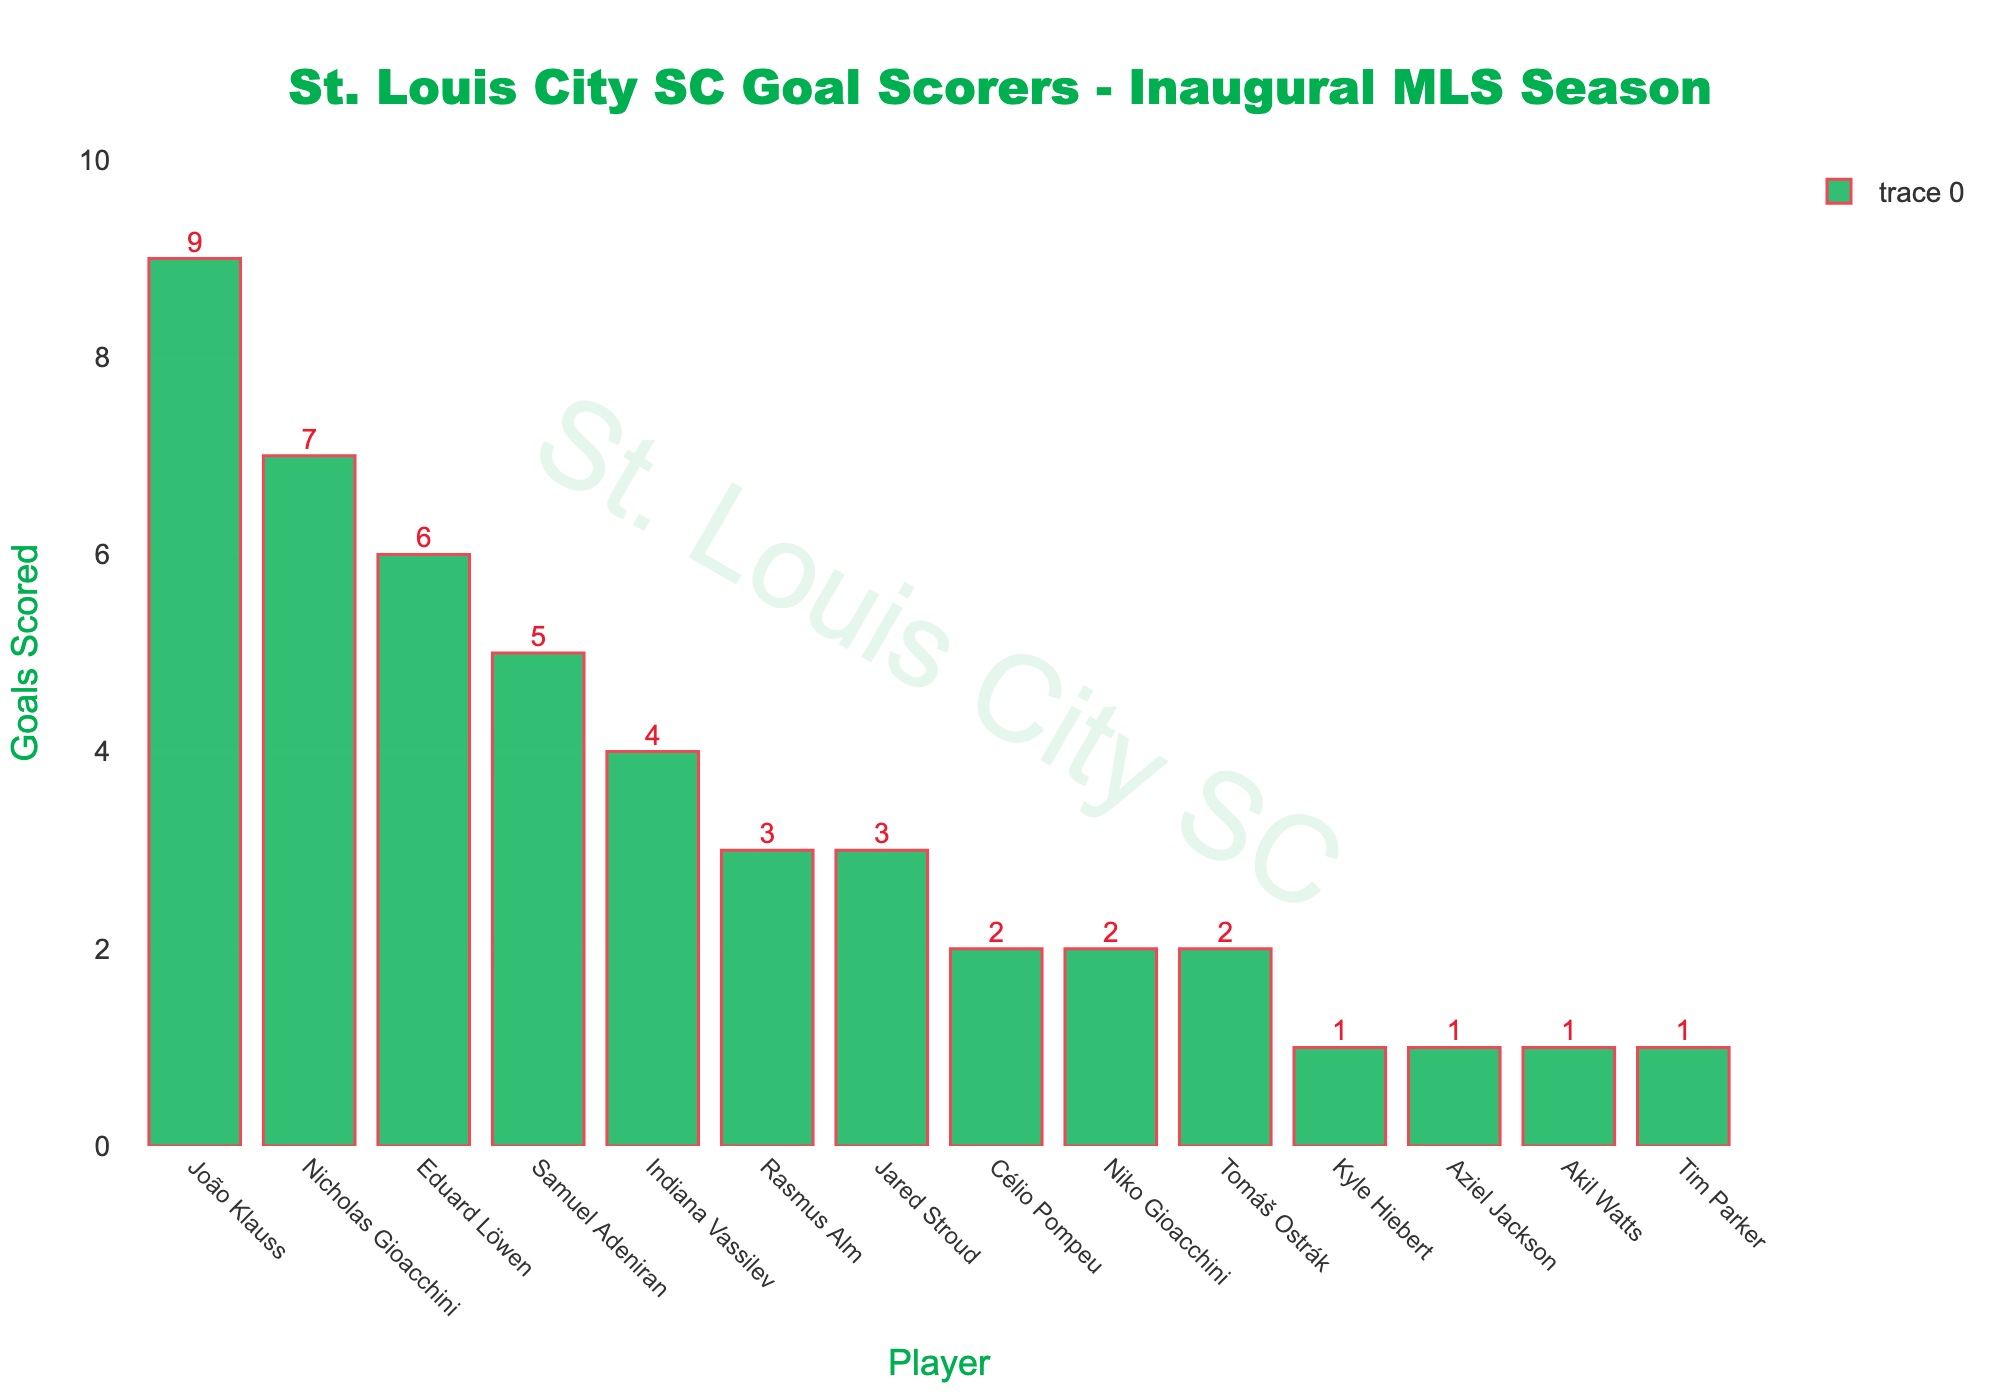What's the total number of goals scored by the top three goal scorers? The top three goal scorers are João Klauss (9 goals), Nicholas Gioacchini (7 goals), and Eduard Löwen (6 goals). Adding their goals together: 9 + 7 + 6 = 22.
Answer: 22 Who scored more goals, Indiana Vassilev or Samuel Adeniran? According to the bar chart, Indiana Vassilev scored 4 goals, while Samuel Adeniran scored 5 goals. Therefore, Samuel Adeniran scored more goals.
Answer: Samuel Adeniran What is the difference in goals scored between the player with the most goals and the player with the least goals? The player with the most goals is João Klauss with 9 goals. The players with the least goals (1 each) are Kyle Hiebert, Aziel Jackson, Akil Watts, and Tim Parker. The difference between 9 (most goals) and 1 (least goals) is: 9 - 1 = 8.
Answer: 8 Which players scored exactly 3 goals? The bar chart shows that both Rasmus Alm and Jared Stroud scored exactly 3 goals each.
Answer: Rasmus Alm and Jared Stroud How many players scored more than 5 goals? Referring to the bar chart, only three players scored more than 5 goals: João Klauss (9), Nicholas Gioacchini (7), and Eduard Löwen (6).
Answer: 3 What is the total number of goals scored by the team? Sum each player's goals: 9 (João Klauss) + 7 (Nicholas Gioacchini) + 6 (Eduard Löwen) + 5 (Samuel Adeniran) + 4 (Indiana Vassilev) + 3 (Rasmus Alm) + 3 (Jared Stroud) + 2 (Célio Pompeu) + 2 (Niko Gioacchini) + 2 (Tomáš Ostrák) + 1 (Kyle Hiebert) + 1 (Aziel Jackson) + 1 (Akil Watts) + 1 (Tim Parker) = 47.
Answer: 47 Which player has the shortest bar in the chart? The shortest bar corresponds to the players who scored 1 goal each: Kyle Hiebert, Aziel Jackson, Akil Watts, and Tim Parker.
Answer: Kyle Hiebert, Aziel Jackson, Akil Watts, and Tim Parker 